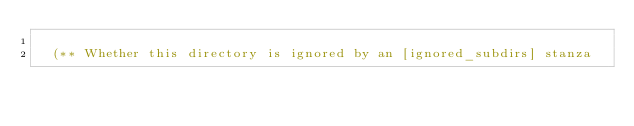<code> <loc_0><loc_0><loc_500><loc_500><_OCaml_>
  (** Whether this directory is ignored by an [ignored_subdirs] stanza</code> 